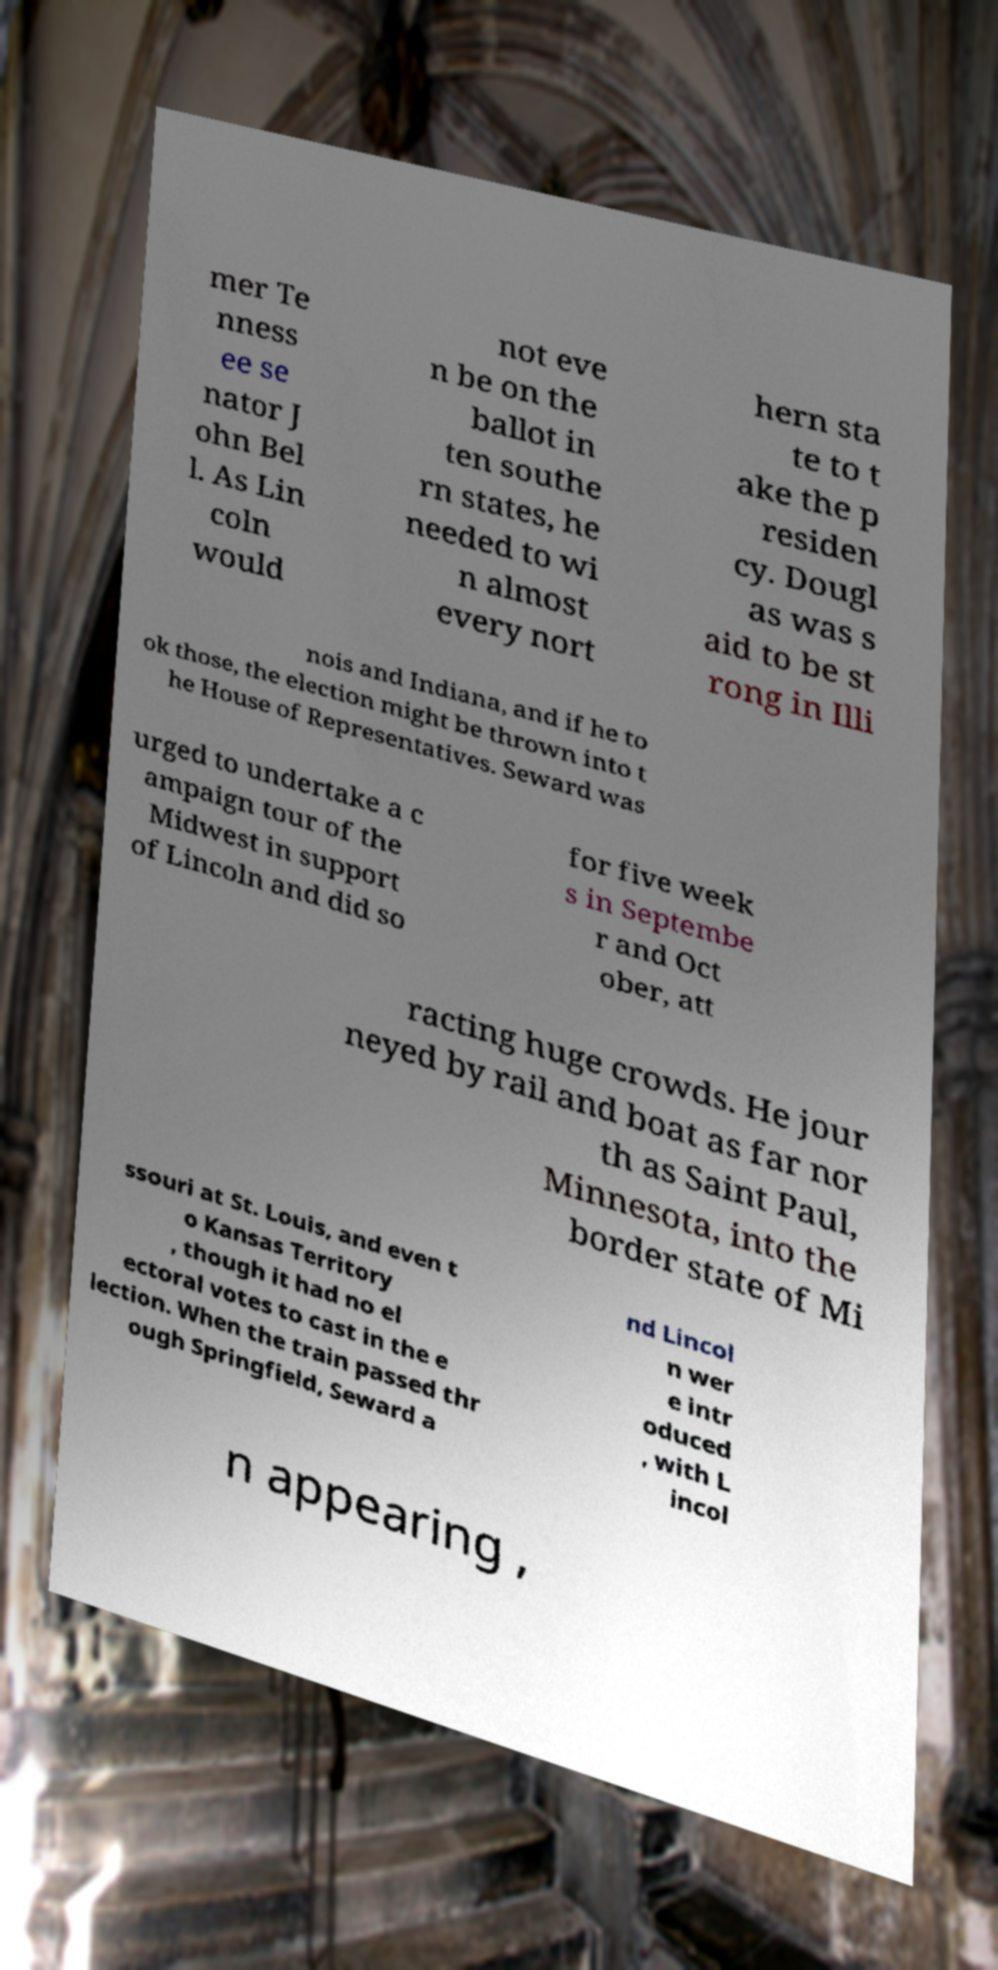I need the written content from this picture converted into text. Can you do that? mer Te nness ee se nator J ohn Bel l. As Lin coln would not eve n be on the ballot in ten southe rn states, he needed to wi n almost every nort hern sta te to t ake the p residen cy. Dougl as was s aid to be st rong in Illi nois and Indiana, and if he to ok those, the election might be thrown into t he House of Representatives. Seward was urged to undertake a c ampaign tour of the Midwest in support of Lincoln and did so for five week s in Septembe r and Oct ober, att racting huge crowds. He jour neyed by rail and boat as far nor th as Saint Paul, Minnesota, into the border state of Mi ssouri at St. Louis, and even t o Kansas Territory , though it had no el ectoral votes to cast in the e lection. When the train passed thr ough Springfield, Seward a nd Lincol n wer e intr oduced , with L incol n appearing , 